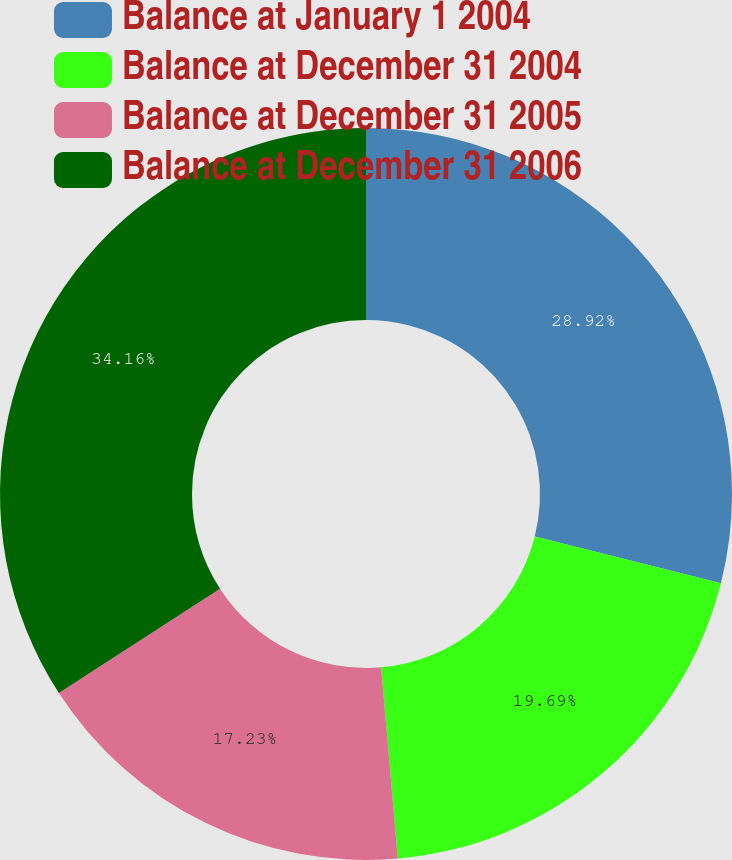Convert chart to OTSL. <chart><loc_0><loc_0><loc_500><loc_500><pie_chart><fcel>Balance at January 1 2004<fcel>Balance at December 31 2004<fcel>Balance at December 31 2005<fcel>Balance at December 31 2006<nl><fcel>28.92%<fcel>19.69%<fcel>17.23%<fcel>34.15%<nl></chart> 